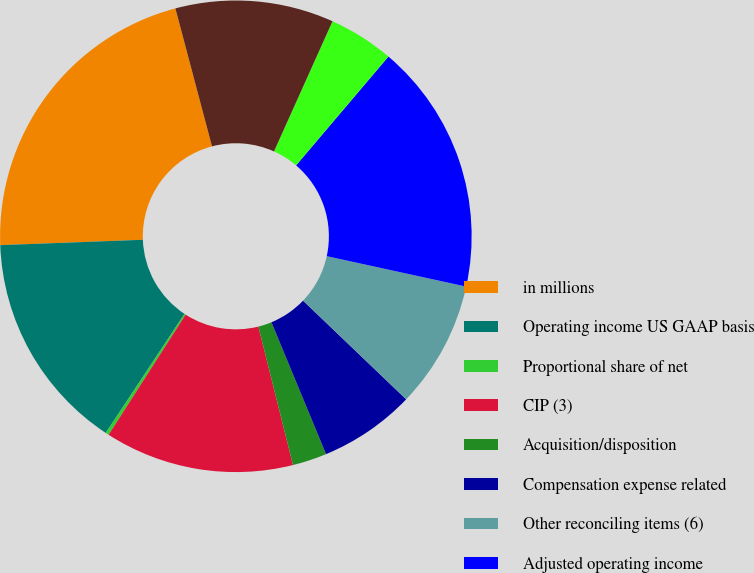Convert chart to OTSL. <chart><loc_0><loc_0><loc_500><loc_500><pie_chart><fcel>in millions<fcel>Operating income US GAAP basis<fcel>Proportional share of net<fcel>CIP (3)<fcel>Acquisition/disposition<fcel>Compensation expense related<fcel>Other reconciling items (6)<fcel>Adjusted operating income<fcel>Operating margin<fcel>Adjusted operating margin<nl><fcel>21.47%<fcel>15.1%<fcel>0.23%<fcel>12.97%<fcel>2.35%<fcel>6.6%<fcel>8.73%<fcel>17.22%<fcel>4.48%<fcel>10.85%<nl></chart> 